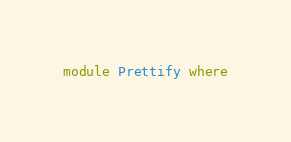Convert code to text. <code><loc_0><loc_0><loc_500><loc_500><_Haskell_>module Prettify where
</code> 